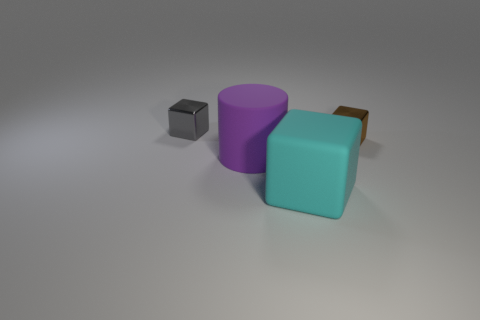What shape is the tiny object to the left of the small metal thing that is right of the cube to the left of the purple object?
Provide a succinct answer. Cube. The object that is both to the right of the tiny gray object and left of the cyan rubber block has what shape?
Make the answer very short. Cylinder. How many objects are yellow shiny cylinders or metallic things that are in front of the gray thing?
Offer a terse response. 1. Is the cyan object made of the same material as the brown object?
Offer a very short reply. No. How many other things are the same shape as the purple thing?
Offer a terse response. 0. There is a object that is both on the left side of the matte cube and on the right side of the tiny gray block; how big is it?
Ensure brevity in your answer.  Large. How many rubber objects are cyan things or small cubes?
Give a very brief answer. 1. There is a tiny metal thing that is right of the tiny gray metallic cube; does it have the same shape as the tiny thing to the left of the cyan thing?
Make the answer very short. Yes. Is there a tiny green sphere made of the same material as the cylinder?
Your answer should be very brief. No. What color is the large rubber cylinder?
Your answer should be compact. Purple. 